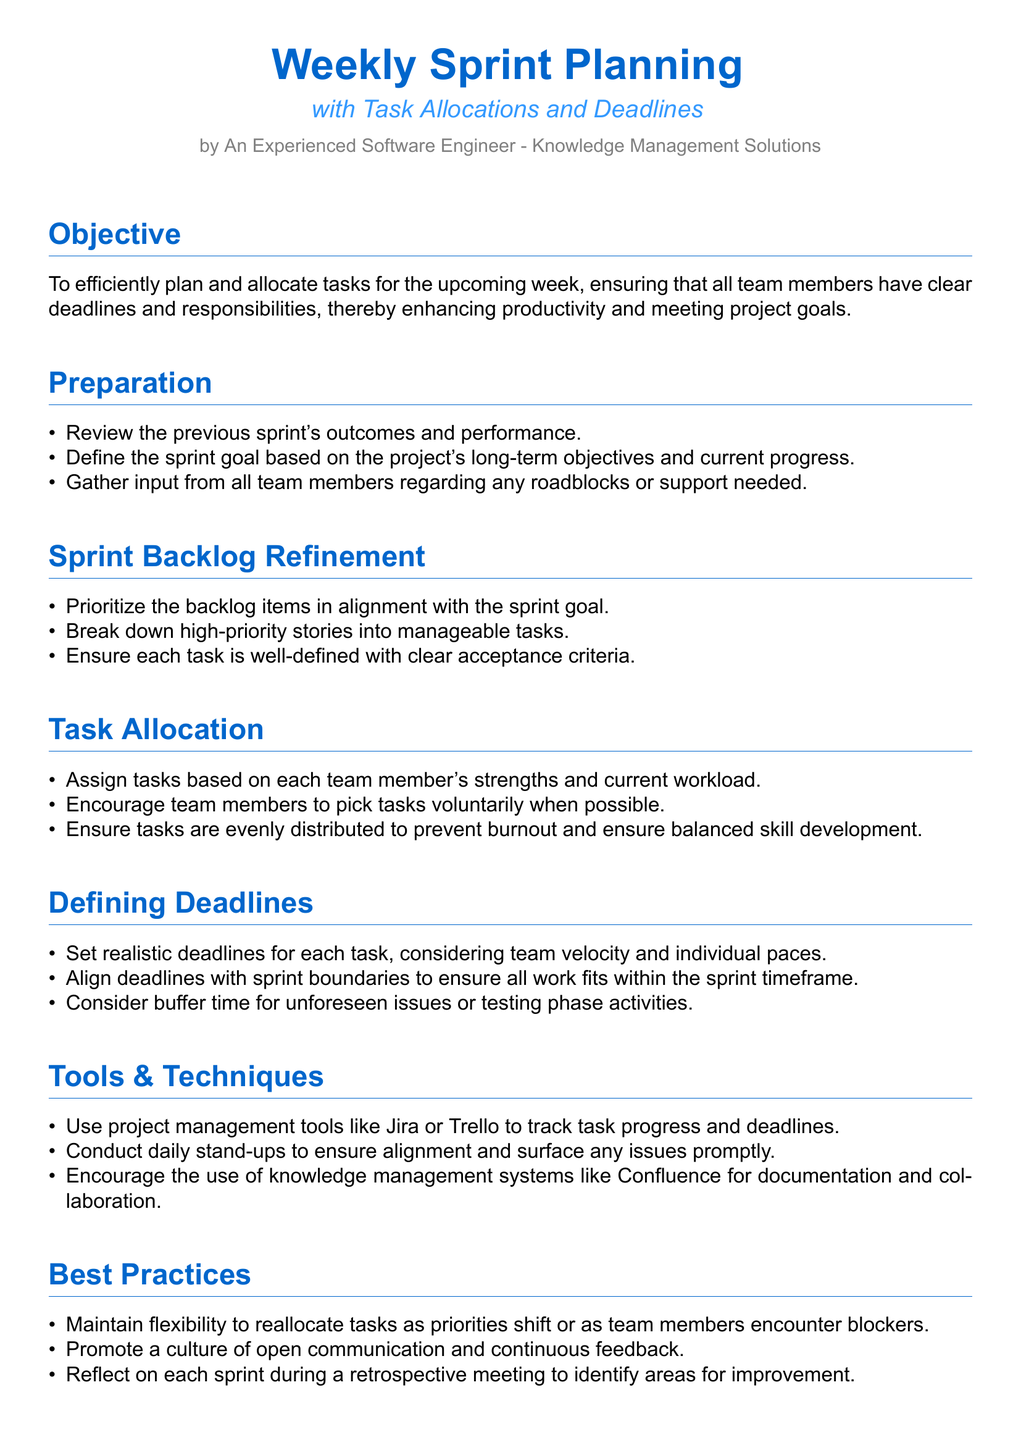What is the main objective of weekly sprint planning? The objective is to efficiently plan and allocate tasks for the upcoming week, ensuring clear deadlines and responsibilities to enhance productivity and meet project goals.
Answer: Enhance productivity How many sections are there in the document? The document contains several sections, which can be counted as 6 main sections, including Objective, Preparation, Sprint Backlog Refinement, Task Allocation, Defining Deadlines, Tools & Techniques, Best Practices, and Conclusion.
Answer: 8 What should be reviewed before planning the next sprint? Review the previous sprint's outcomes and performance to inform planning.
Answer: Previous sprint's outcomes What tools are suggested for tracking progress? The document suggests using project management tools like Jira or Trello to track task progress.
Answer: Jira or Trello What is one of the best practices mentioned? One of the best practices highlighted is to maintain flexibility to reallocate tasks as priorities shift.
Answer: Maintain flexibility How should tasks be assigned to team members? Tasks should be assigned based on each team member's strengths and current workload to maximize efficiency.
Answer: Based on strengths and workload What is the purpose of setting deadlines for tasks? Setting realistic deadlines helps ensure all work fits within the sprint timeframe and considers team velocity.
Answer: Fit within sprint timeframe Which section discusses the importance of team communication? The section titled "Best Practices" emphasizes the importance of a culture of open communication and continuous feedback among team members.
Answer: Best Practices 